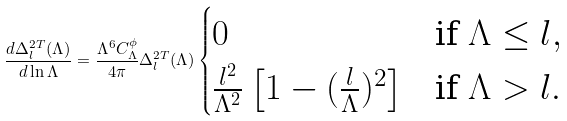<formula> <loc_0><loc_0><loc_500><loc_500>\frac { d \Delta ^ { 2 T } _ { l } ( \Lambda ) } { d \ln \Lambda } = \frac { \Lambda ^ { 6 } C ^ { \phi } _ { \Lambda } } { 4 \pi } \Delta ^ { 2 T } _ { l } ( \Lambda ) \begin{cases} 0 & \text {if $\Lambda \leq l$} , \\ \frac { l ^ { 2 } } { \Lambda ^ { 2 } } \left [ 1 - ( \frac { l } { \Lambda } ) ^ { 2 } \right ] & \text {if $\Lambda > l$} . \end{cases}</formula> 